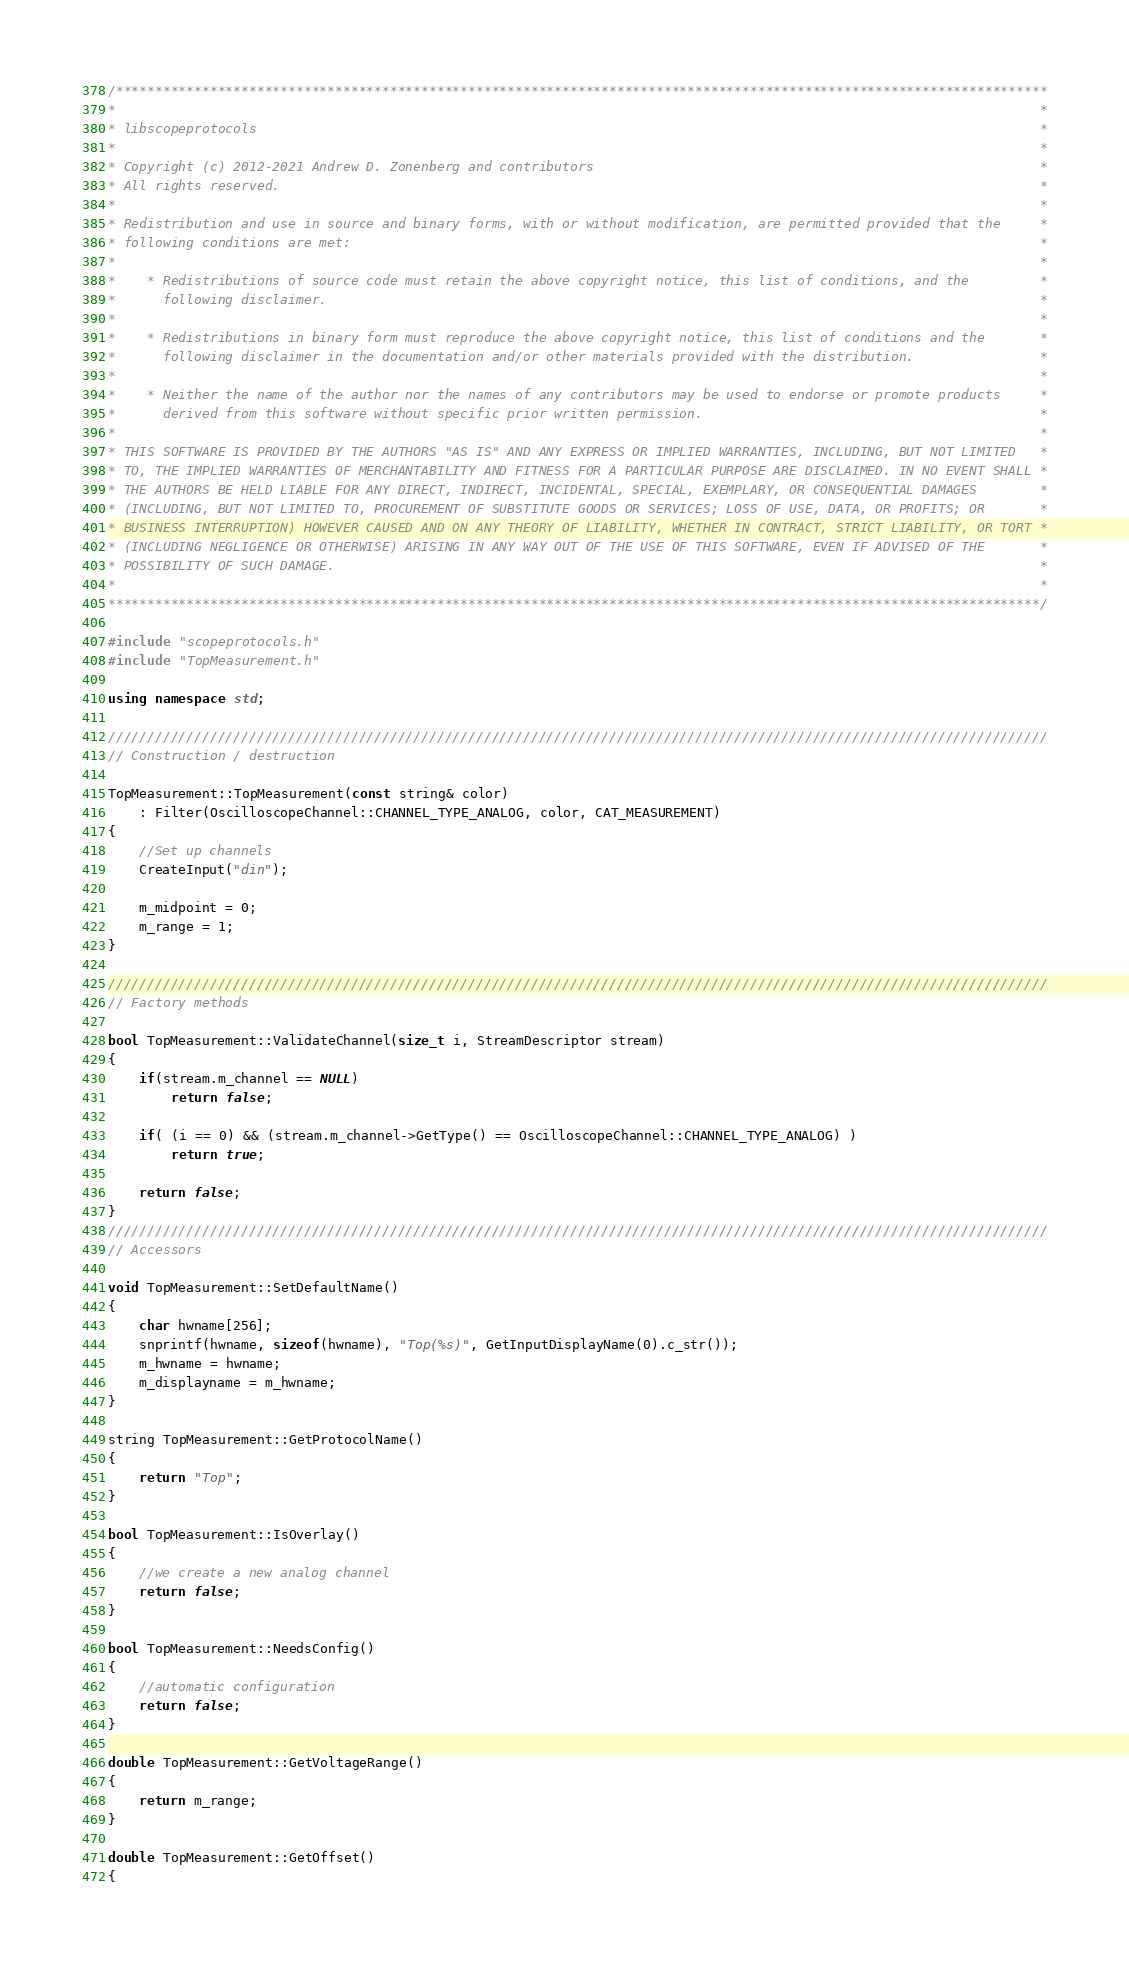<code> <loc_0><loc_0><loc_500><loc_500><_C++_>/***********************************************************************************************************************
*                                                                                                                      *
* libscopeprotocols                                                                                                    *
*                                                                                                                      *
* Copyright (c) 2012-2021 Andrew D. Zonenberg and contributors                                                         *
* All rights reserved.                                                                                                 *
*                                                                                                                      *
* Redistribution and use in source and binary forms, with or without modification, are permitted provided that the     *
* following conditions are met:                                                                                        *
*                                                                                                                      *
*    * Redistributions of source code must retain the above copyright notice, this list of conditions, and the         *
*      following disclaimer.                                                                                           *
*                                                                                                                      *
*    * Redistributions in binary form must reproduce the above copyright notice, this list of conditions and the       *
*      following disclaimer in the documentation and/or other materials provided with the distribution.                *
*                                                                                                                      *
*    * Neither the name of the author nor the names of any contributors may be used to endorse or promote products     *
*      derived from this software without specific prior written permission.                                           *
*                                                                                                                      *
* THIS SOFTWARE IS PROVIDED BY THE AUTHORS "AS IS" AND ANY EXPRESS OR IMPLIED WARRANTIES, INCLUDING, BUT NOT LIMITED   *
* TO, THE IMPLIED WARRANTIES OF MERCHANTABILITY AND FITNESS FOR A PARTICULAR PURPOSE ARE DISCLAIMED. IN NO EVENT SHALL *
* THE AUTHORS BE HELD LIABLE FOR ANY DIRECT, INDIRECT, INCIDENTAL, SPECIAL, EXEMPLARY, OR CONSEQUENTIAL DAMAGES        *
* (INCLUDING, BUT NOT LIMITED TO, PROCUREMENT OF SUBSTITUTE GOODS OR SERVICES; LOSS OF USE, DATA, OR PROFITS; OR       *
* BUSINESS INTERRUPTION) HOWEVER CAUSED AND ON ANY THEORY OF LIABILITY, WHETHER IN CONTRACT, STRICT LIABILITY, OR TORT *
* (INCLUDING NEGLIGENCE OR OTHERWISE) ARISING IN ANY WAY OUT OF THE USE OF THIS SOFTWARE, EVEN IF ADVISED OF THE       *
* POSSIBILITY OF SUCH DAMAGE.                                                                                          *
*                                                                                                                      *
***********************************************************************************************************************/

#include "scopeprotocols.h"
#include "TopMeasurement.h"

using namespace std;

////////////////////////////////////////////////////////////////////////////////////////////////////////////////////////
// Construction / destruction

TopMeasurement::TopMeasurement(const string& color)
	: Filter(OscilloscopeChannel::CHANNEL_TYPE_ANALOG, color, CAT_MEASUREMENT)
{
	//Set up channels
	CreateInput("din");

	m_midpoint = 0;
	m_range = 1;
}

////////////////////////////////////////////////////////////////////////////////////////////////////////////////////////
// Factory methods

bool TopMeasurement::ValidateChannel(size_t i, StreamDescriptor stream)
{
	if(stream.m_channel == NULL)
		return false;

	if( (i == 0) && (stream.m_channel->GetType() == OscilloscopeChannel::CHANNEL_TYPE_ANALOG) )
		return true;

	return false;
}
////////////////////////////////////////////////////////////////////////////////////////////////////////////////////////
// Accessors

void TopMeasurement::SetDefaultName()
{
	char hwname[256];
	snprintf(hwname, sizeof(hwname), "Top(%s)", GetInputDisplayName(0).c_str());
	m_hwname = hwname;
	m_displayname = m_hwname;
}

string TopMeasurement::GetProtocolName()
{
	return "Top";
}

bool TopMeasurement::IsOverlay()
{
	//we create a new analog channel
	return false;
}

bool TopMeasurement::NeedsConfig()
{
	//automatic configuration
	return false;
}

double TopMeasurement::GetVoltageRange()
{
	return m_range;
}

double TopMeasurement::GetOffset()
{</code> 